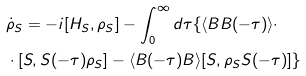Convert formula to latex. <formula><loc_0><loc_0><loc_500><loc_500>& \dot { \rho } _ { S } = - i [ H _ { S } , \rho _ { S } ] - \int _ { 0 } ^ { \infty } d \tau \{ \langle B B ( - \tau ) \rangle \cdot \\ & \cdot [ S , S ( - \tau ) \rho _ { S } ] - \langle B ( - \tau ) B \rangle [ S , \rho _ { S } S ( - \tau ) ] \} \\</formula> 